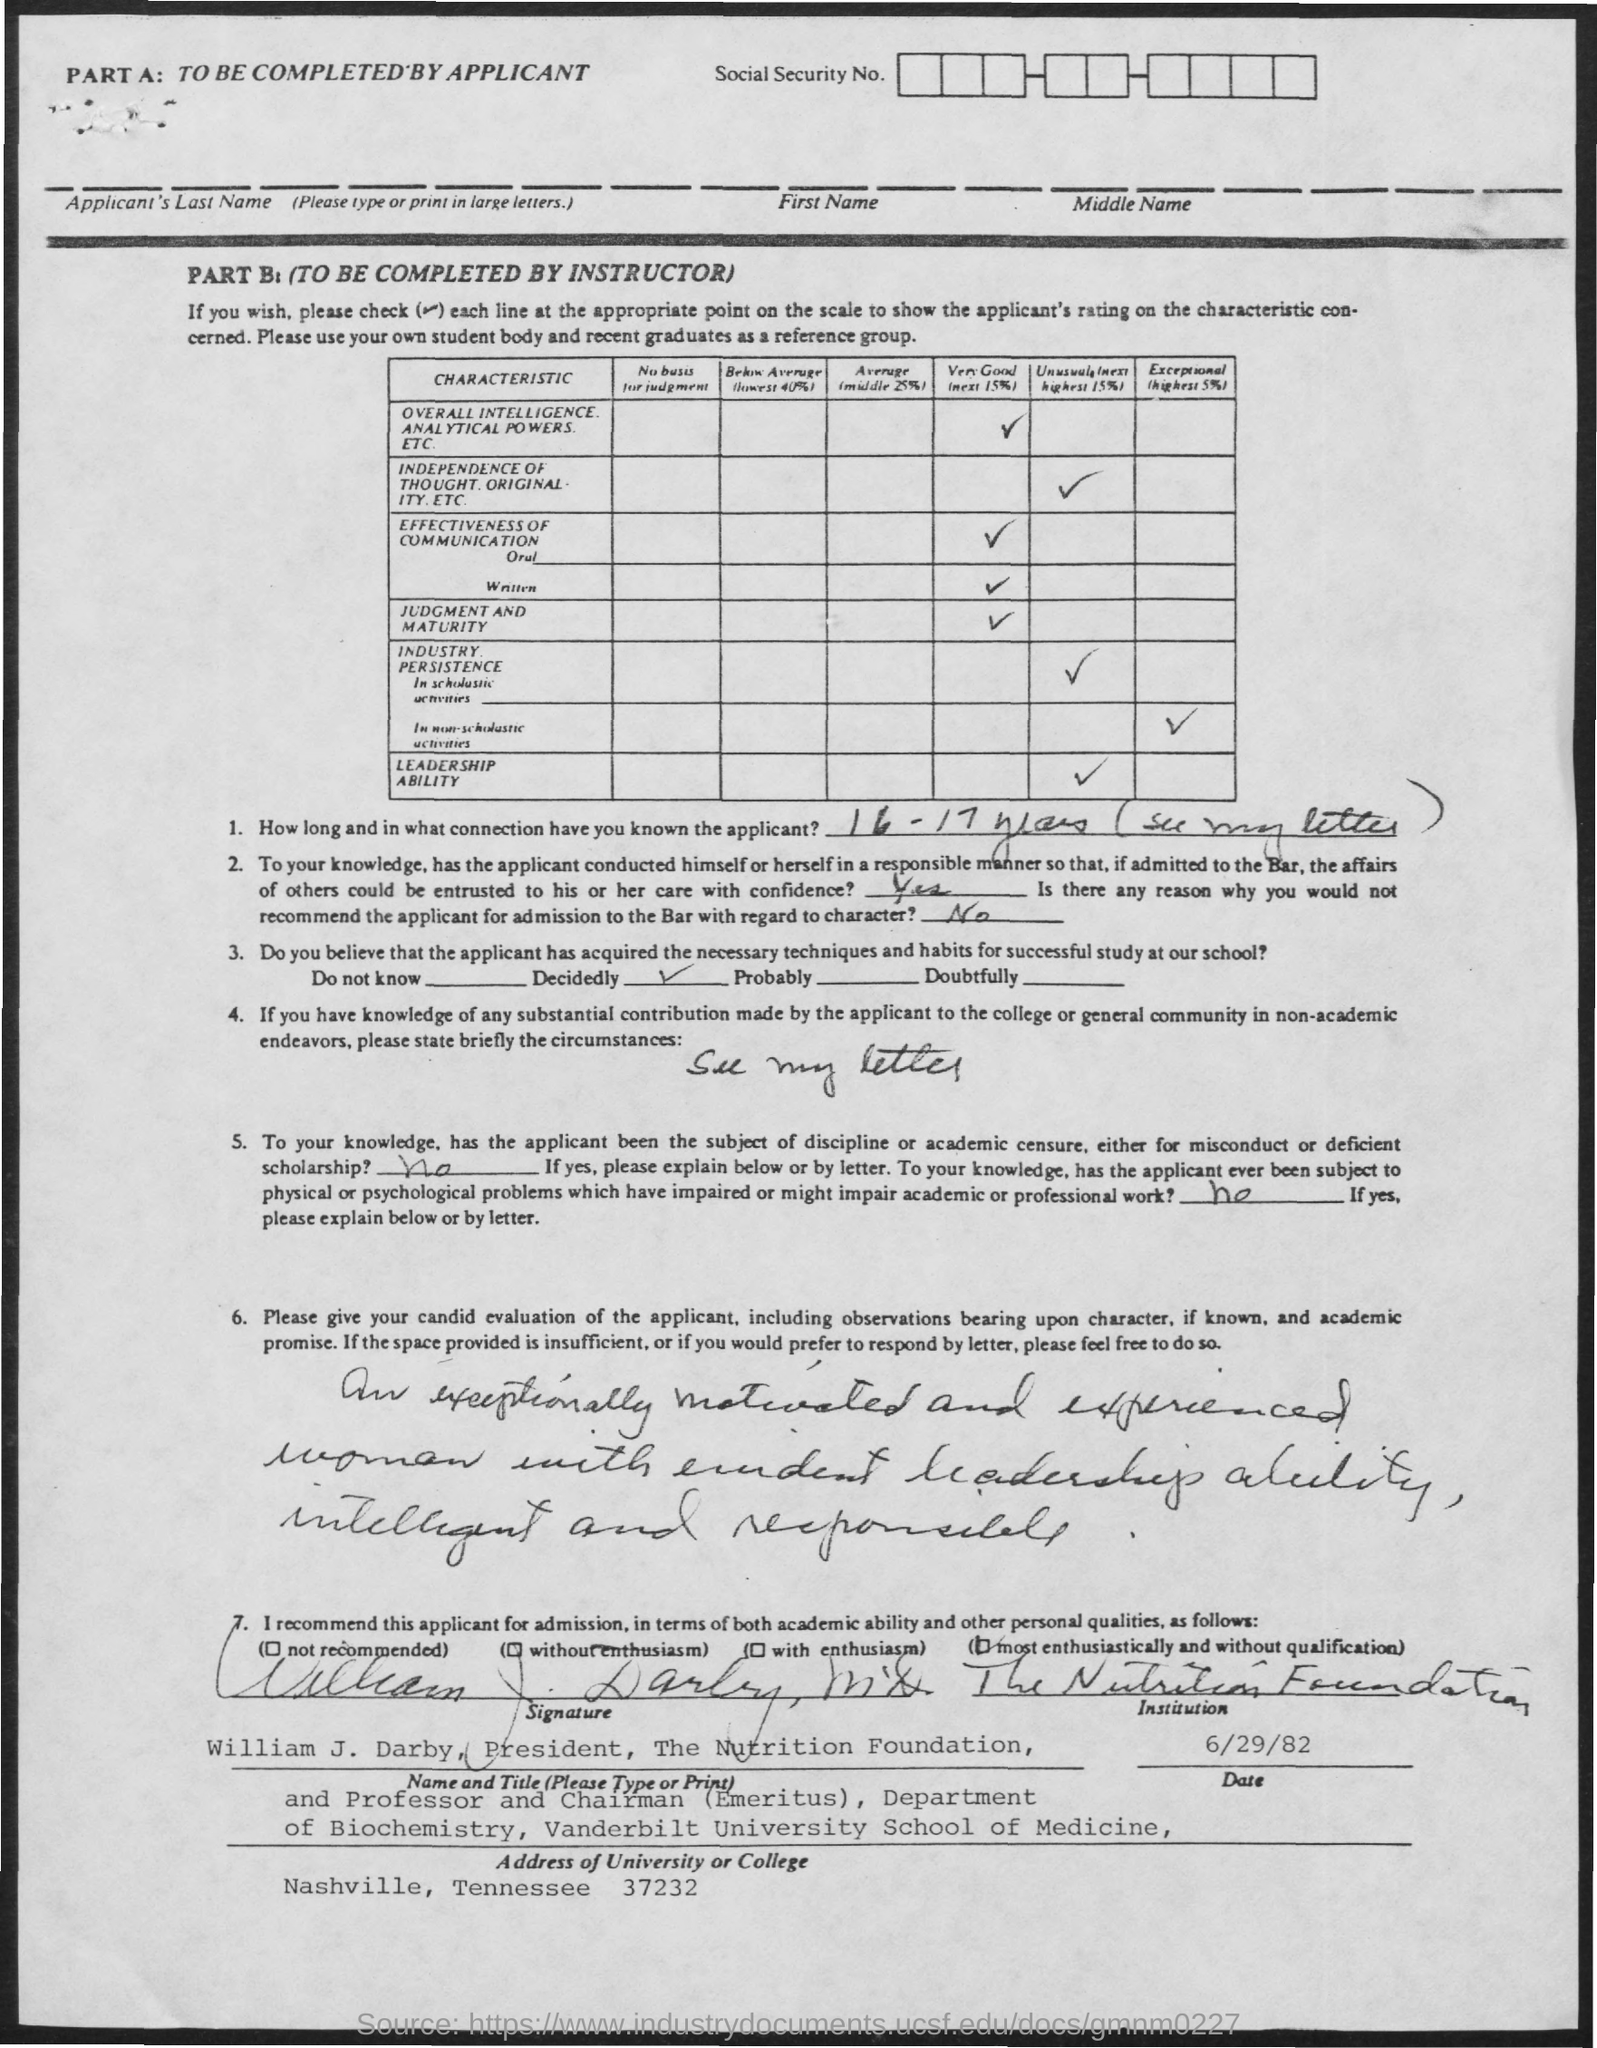Highlight a few significant elements in this photo. The date mentioned in the given page is 6/29/82. The signature at the bottom of the letter was that of William J. Darby. The university or college located in Nashville, Tennessee, is situated at 37232. 